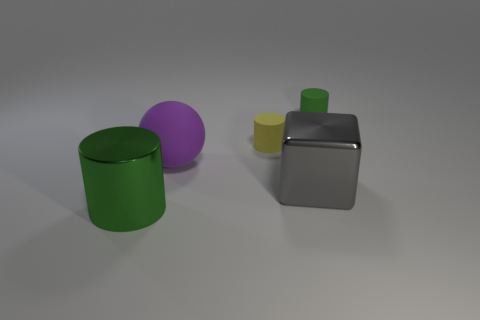How do the shadows contribute to the perception of the image? The shadows cast by each object add depth and a sense of realism to the scene. They provide clues about the light source direction, suggesting it's coming from the upper left. The shadows help to anchor the objects in space, giving the viewer a better understanding of their relative positions and sizes. Could the lighting be improved for better clarity? Indeed, adjusting the lighting to be more diffuse could reduce harsh shadows and offer a clearer perception of each object's color and texture. Alternatively, multiple light sources could be used to minimize confusing overlaps of shadows and highlight more details of the objects. 